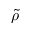<formula> <loc_0><loc_0><loc_500><loc_500>\tilde { \rho }</formula> 